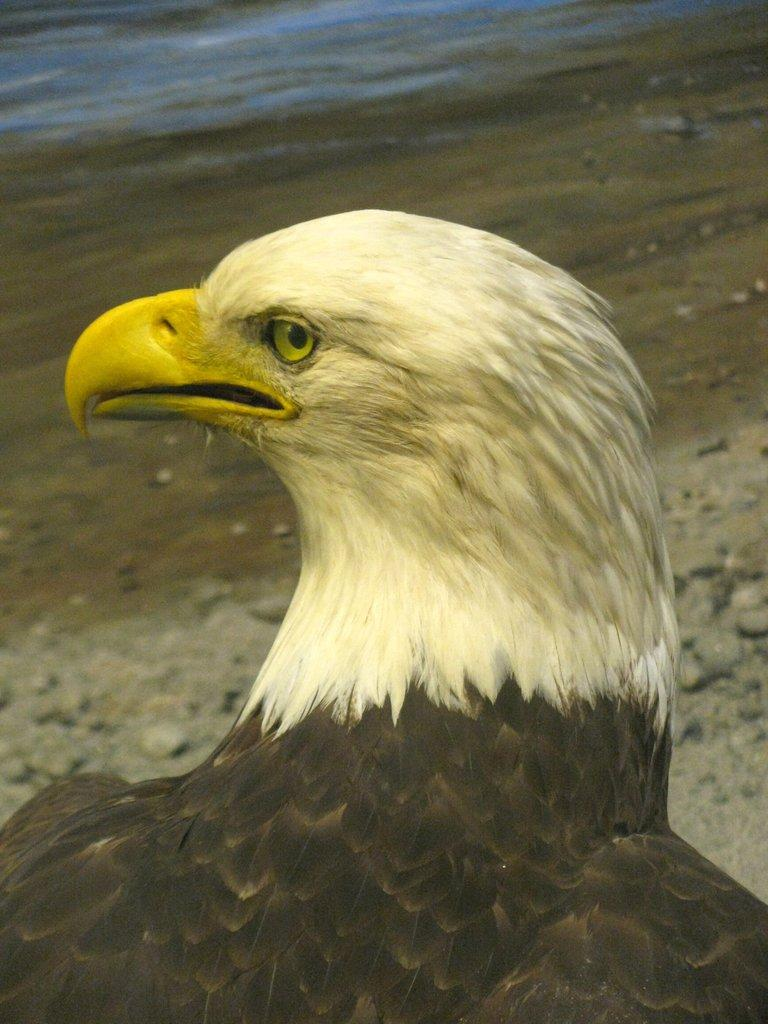What type of animal is in the image? There is a bird in the image. Where is the bird located in relation to the image? The bird is in the front of the image. What can be seen in the background of the image? There is land visible in the background of the image. What type of prose is being recited by the bird in the image? There is no indication in the image that the bird is reciting any prose, as birds do not have the ability to speak or recite literature. 